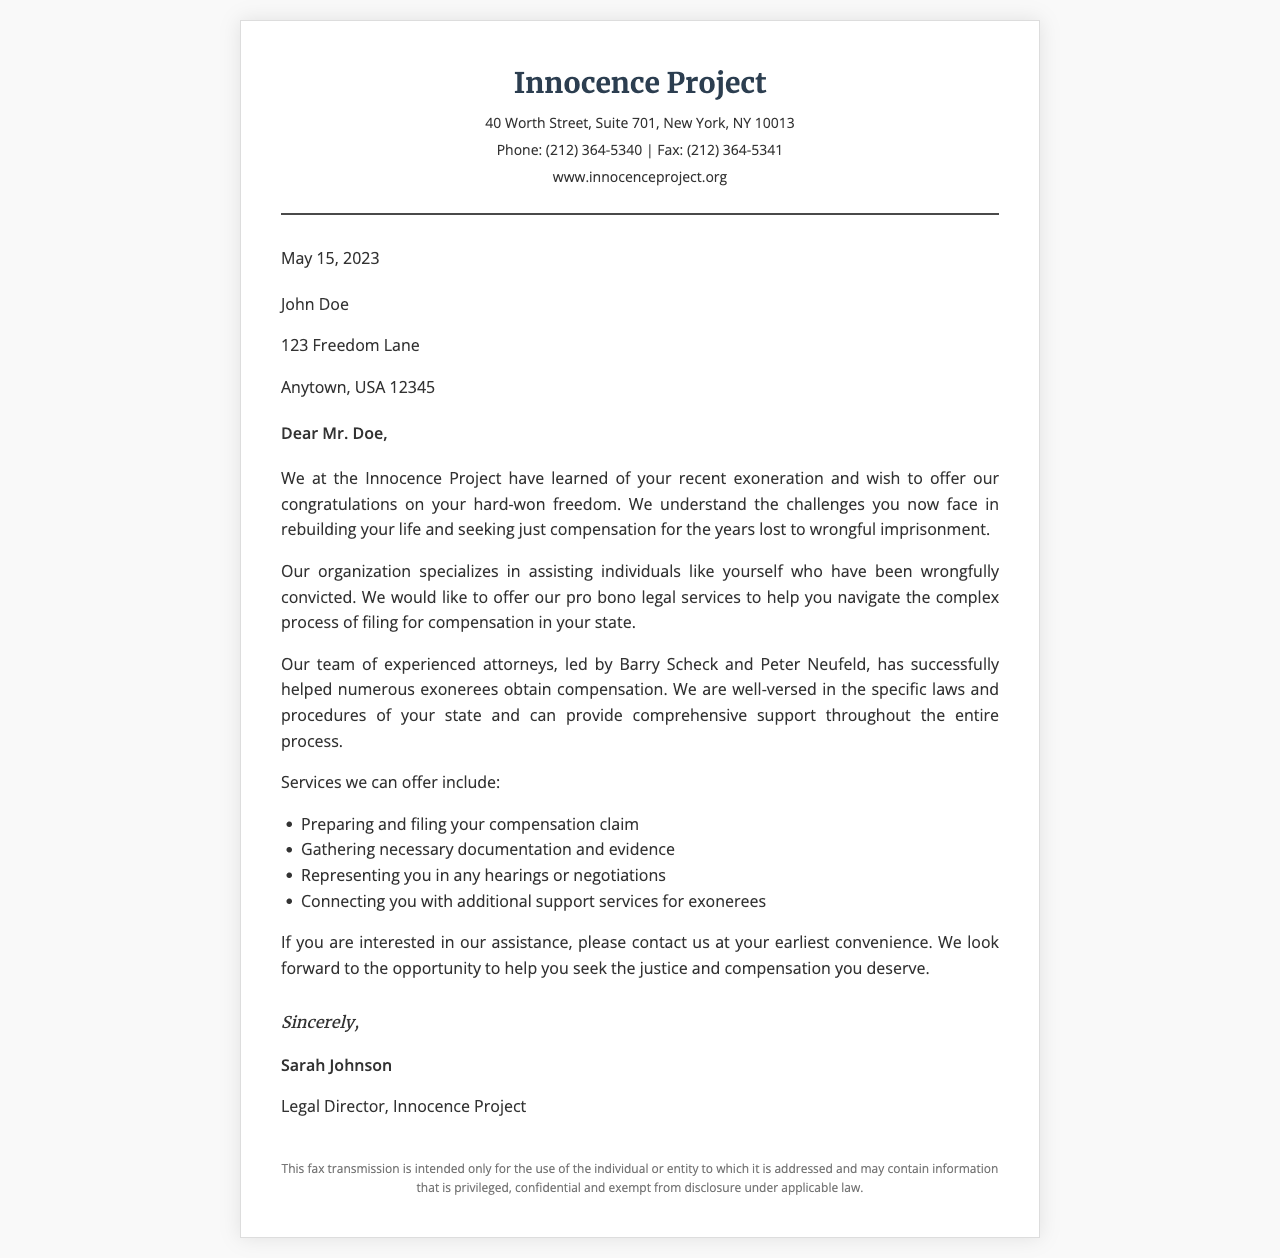What is the name of the organization offering legal assistance? The document mentions the Innocence Project as the organization providing legal help to exonerees.
Answer: Innocence Project Who is the legal director of the organization? The signature in the document indicates that Sarah Johnson is the Legal Director at the Innocence Project.
Answer: Sarah Johnson What is the date of the letter? The date provided at the top of the document states when the letter was written, which is May 15, 2023.
Answer: May 15, 2023 What services does the organization offer? The document lists several services offered, including preparing and filing your compensation claim and gathering necessary documentation and evidence.
Answer: Preparing and filing your compensation claim What is the address of the Innocence Project? The letterhead provides the full address of the organization, which is essential for contact purposes.
Answer: 40 Worth Street, Suite 701, New York, NY 10013 What should John Doe do if he is interested in the assistance? The document advises that John Doe should contact the organization if he is interested in their help regarding compensation.
Answer: Contact us Why does the organization mention the names Barry Scheck and Peter Neufeld? These individuals are mentioned as part of the experienced attorneys at the Innocence Project, highlighting the qualifications of the team.
Answer: Experienced attorneys What type of assistance does the Innocence Project specialize in? The document specifically states that the organization specializes in helping individuals who have been wrongfully convicted.
Answer: Wrongfully convicted What is the fax number for the Innocence Project? The contact information includes the fax number, which is relevant for communication.
Answer: (212) 364-5341 